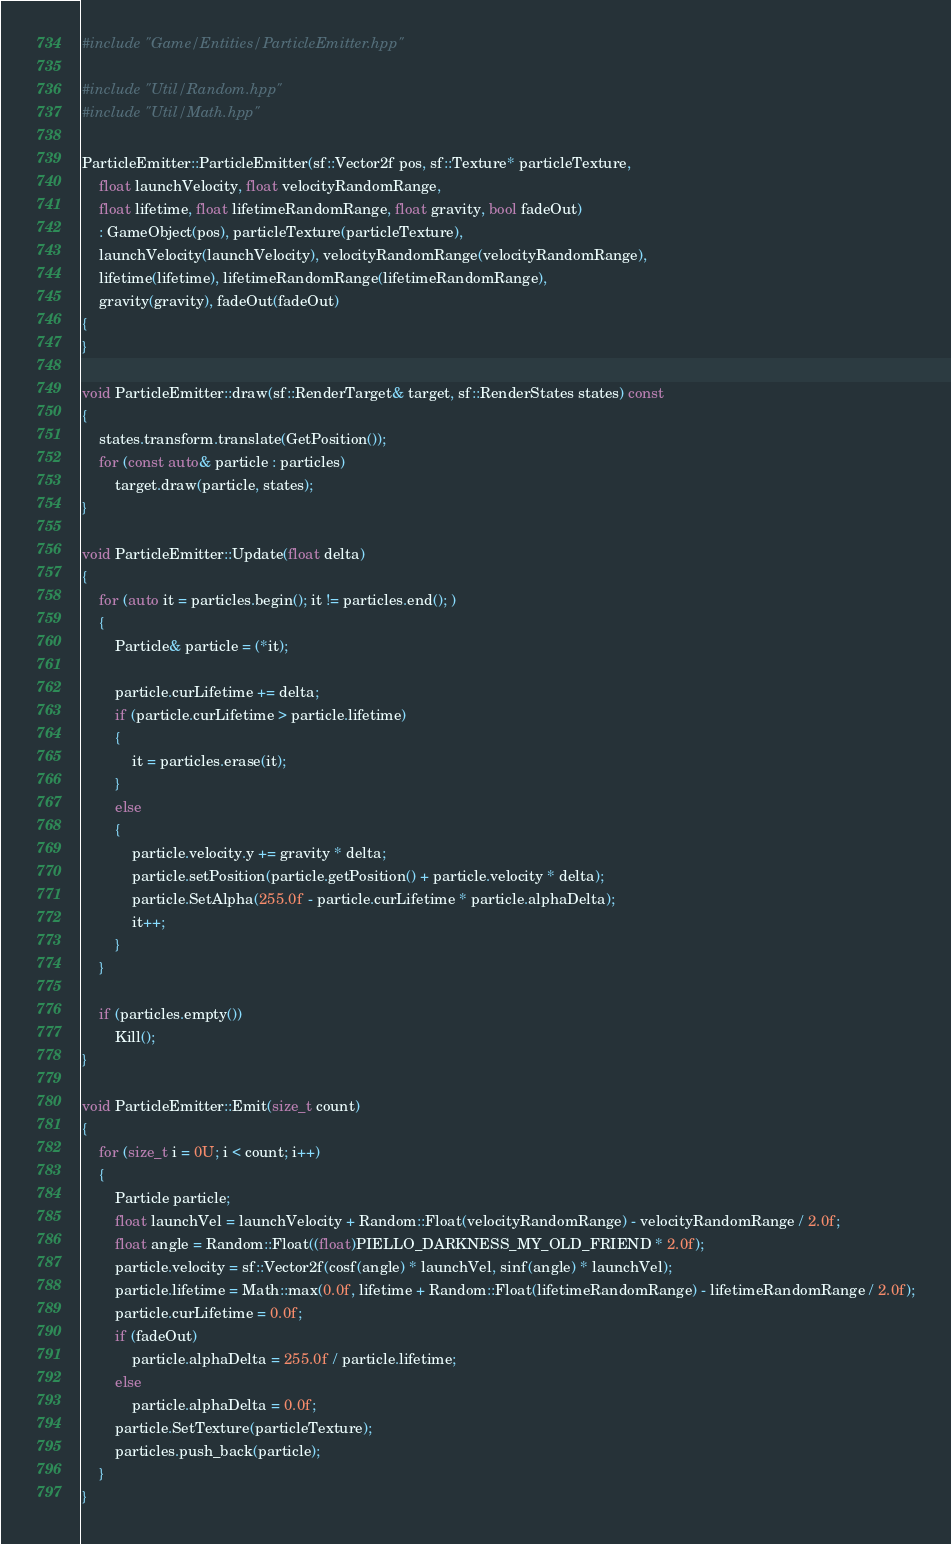Convert code to text. <code><loc_0><loc_0><loc_500><loc_500><_C++_>#include "Game/Entities/ParticleEmitter.hpp"

#include "Util/Random.hpp"
#include "Util/Math.hpp"

ParticleEmitter::ParticleEmitter(sf::Vector2f pos, sf::Texture* particleTexture,
	float launchVelocity, float velocityRandomRange,
	float lifetime, float lifetimeRandomRange, float gravity, bool fadeOut)
	: GameObject(pos), particleTexture(particleTexture),
	launchVelocity(launchVelocity), velocityRandomRange(velocityRandomRange),
	lifetime(lifetime), lifetimeRandomRange(lifetimeRandomRange),
	gravity(gravity), fadeOut(fadeOut)
{
}

void ParticleEmitter::draw(sf::RenderTarget& target, sf::RenderStates states) const
{
	states.transform.translate(GetPosition());
	for (const auto& particle : particles)
		target.draw(particle, states);
}

void ParticleEmitter::Update(float delta)
{
	for (auto it = particles.begin(); it != particles.end(); )
	{
		Particle& particle = (*it);

		particle.curLifetime += delta;
		if (particle.curLifetime > particle.lifetime)
		{
			it = particles.erase(it);
		}
		else
		{
			particle.velocity.y += gravity * delta;
			particle.setPosition(particle.getPosition() + particle.velocity * delta);
			particle.SetAlpha(255.0f - particle.curLifetime * particle.alphaDelta);
			it++;
		}
	}

	if (particles.empty())
		Kill();
}

void ParticleEmitter::Emit(size_t count)
{
	for (size_t i = 0U; i < count; i++)
	{
		Particle particle;
		float launchVel = launchVelocity + Random::Float(velocityRandomRange) - velocityRandomRange / 2.0f;
		float angle = Random::Float((float)PIELLO_DARKNESS_MY_OLD_FRIEND * 2.0f);
		particle.velocity = sf::Vector2f(cosf(angle) * launchVel, sinf(angle) * launchVel);
		particle.lifetime = Math::max(0.0f, lifetime + Random::Float(lifetimeRandomRange) - lifetimeRandomRange / 2.0f);
		particle.curLifetime = 0.0f;
		if (fadeOut)
			particle.alphaDelta = 255.0f / particle.lifetime;
		else
			particle.alphaDelta = 0.0f;
		particle.SetTexture(particleTexture);
		particles.push_back(particle);
	}
}
</code> 